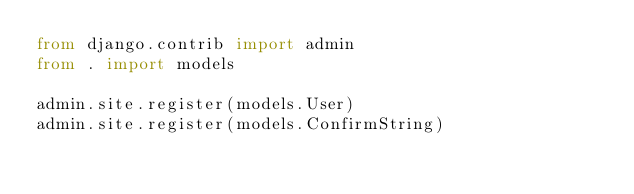<code> <loc_0><loc_0><loc_500><loc_500><_Python_>from django.contrib import admin
from . import models

admin.site.register(models.User)
admin.site.register(models.ConfirmString)
</code> 